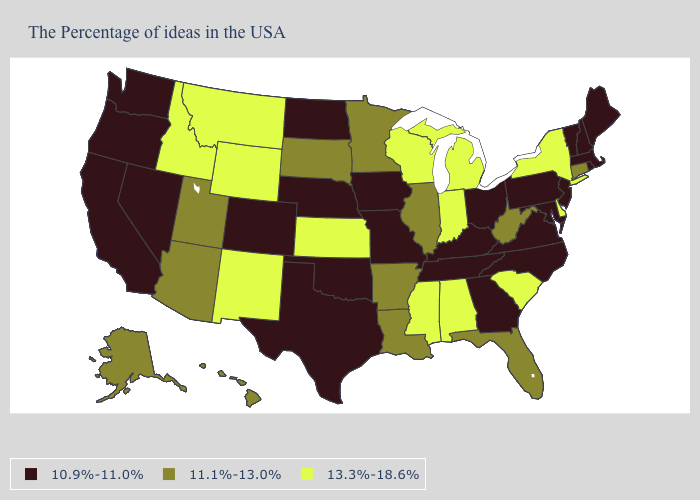Among the states that border Wyoming , which have the highest value?
Short answer required. Montana, Idaho. Name the states that have a value in the range 11.1%-13.0%?
Write a very short answer. Connecticut, West Virginia, Florida, Illinois, Louisiana, Arkansas, Minnesota, South Dakota, Utah, Arizona, Alaska, Hawaii. What is the value of Rhode Island?
Concise answer only. 10.9%-11.0%. Among the states that border Rhode Island , which have the lowest value?
Short answer required. Massachusetts. Name the states that have a value in the range 10.9%-11.0%?
Quick response, please. Maine, Massachusetts, Rhode Island, New Hampshire, Vermont, New Jersey, Maryland, Pennsylvania, Virginia, North Carolina, Ohio, Georgia, Kentucky, Tennessee, Missouri, Iowa, Nebraska, Oklahoma, Texas, North Dakota, Colorado, Nevada, California, Washington, Oregon. Does the first symbol in the legend represent the smallest category?
Be succinct. Yes. Does Arizona have a higher value than Alabama?
Quick response, please. No. What is the lowest value in states that border Utah?
Short answer required. 10.9%-11.0%. What is the lowest value in states that border Maryland?
Write a very short answer. 10.9%-11.0%. Name the states that have a value in the range 11.1%-13.0%?
Answer briefly. Connecticut, West Virginia, Florida, Illinois, Louisiana, Arkansas, Minnesota, South Dakota, Utah, Arizona, Alaska, Hawaii. What is the lowest value in the West?
Answer briefly. 10.9%-11.0%. What is the lowest value in states that border Kentucky?
Be succinct. 10.9%-11.0%. Name the states that have a value in the range 10.9%-11.0%?
Write a very short answer. Maine, Massachusetts, Rhode Island, New Hampshire, Vermont, New Jersey, Maryland, Pennsylvania, Virginia, North Carolina, Ohio, Georgia, Kentucky, Tennessee, Missouri, Iowa, Nebraska, Oklahoma, Texas, North Dakota, Colorado, Nevada, California, Washington, Oregon. What is the value of Wyoming?
Quick response, please. 13.3%-18.6%. 